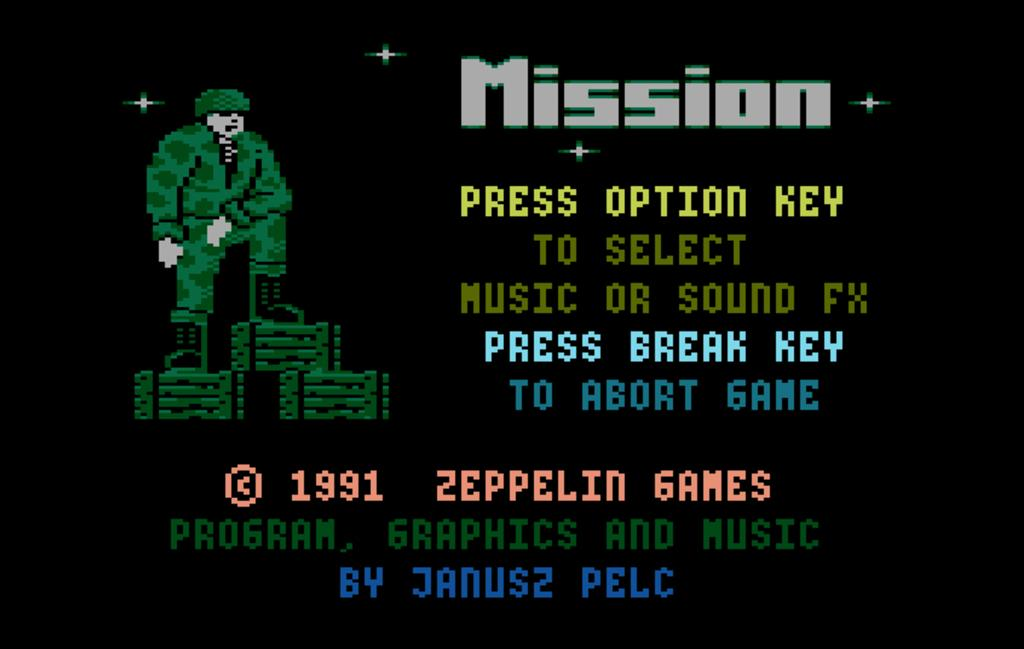What is present on the poster in the image? The poster contains text and an image. Can you describe the image on the poster? Unfortunately, the specific image on the poster cannot be described without more information. What type of content is conveyed through the text on the poster? The content of the text on the poster cannot be determined without more information. What type of music is being played by the quill in the image? There is no quill or music present in the image; it only contains a poster with text and an image. 